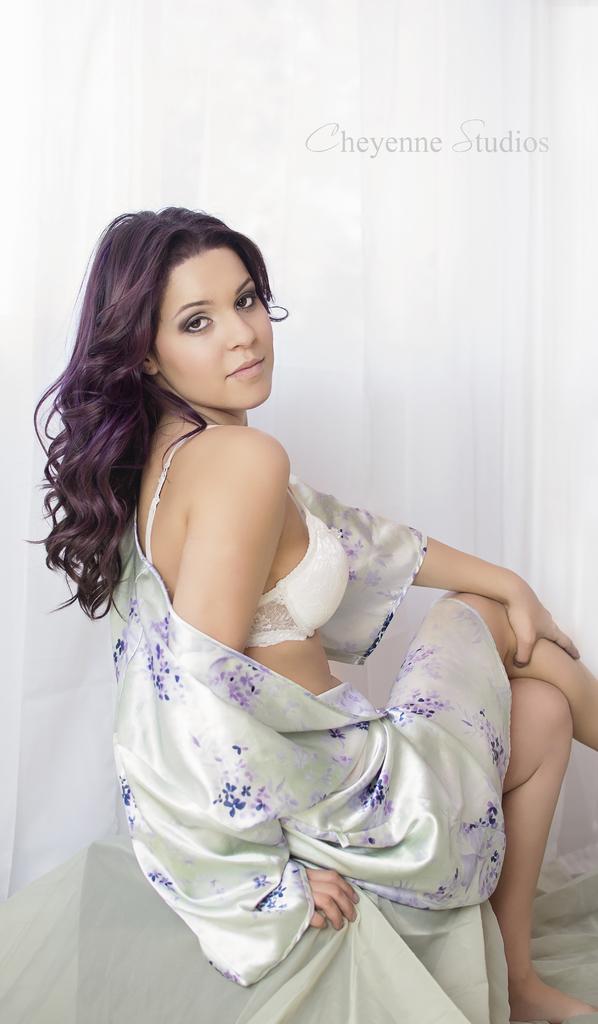Please provide a concise description of this image. In this image I can see a woman is sitting. I can see she is wearing white dress. In background I can see white colour and here I can see watermark. 